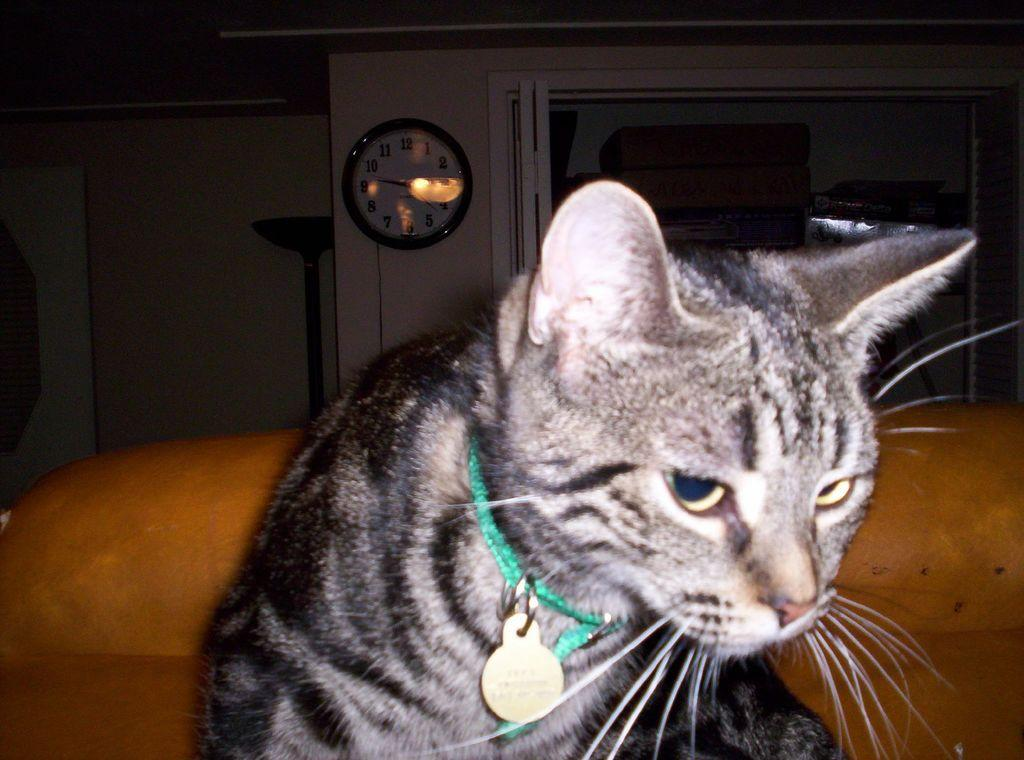What type of animal is in the image? There is a cat in the image. What accessory is the cat wearing? The cat has a locket around its neck. What can be seen on the wall in the background of the image? There is a clock on the wall in the background of the image. What type of vegetable is the cat holding in the image? There is no vegetable present in the image; the cat is not holding anything. 